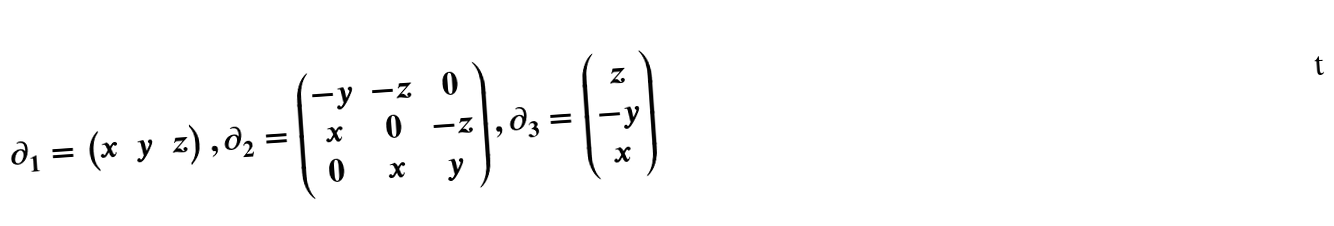<formula> <loc_0><loc_0><loc_500><loc_500>\partial _ { 1 } = \begin{pmatrix} x & y & z \end{pmatrix} , \partial _ { 2 } = \begin{pmatrix} - y & - z & 0 \\ x & 0 & - z \\ 0 & x & y \end{pmatrix} , \partial _ { 3 } = \begin{pmatrix} z \\ - y \\ x \end{pmatrix}</formula> 